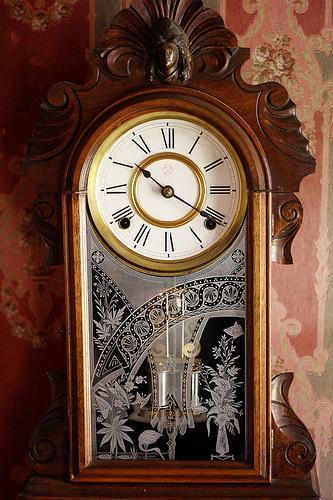How many hands are on the clock?
Give a very brief answer. 2. 